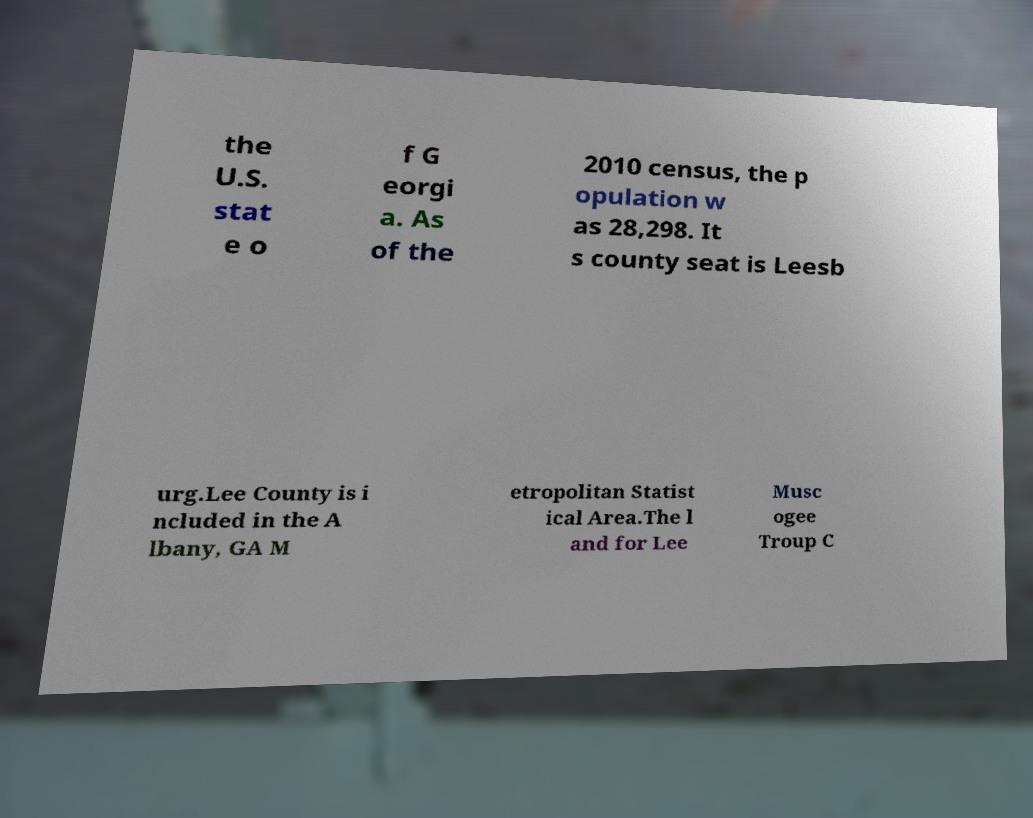I need the written content from this picture converted into text. Can you do that? the U.S. stat e o f G eorgi a. As of the 2010 census, the p opulation w as 28,298. It s county seat is Leesb urg.Lee County is i ncluded in the A lbany, GA M etropolitan Statist ical Area.The l and for Lee Musc ogee Troup C 